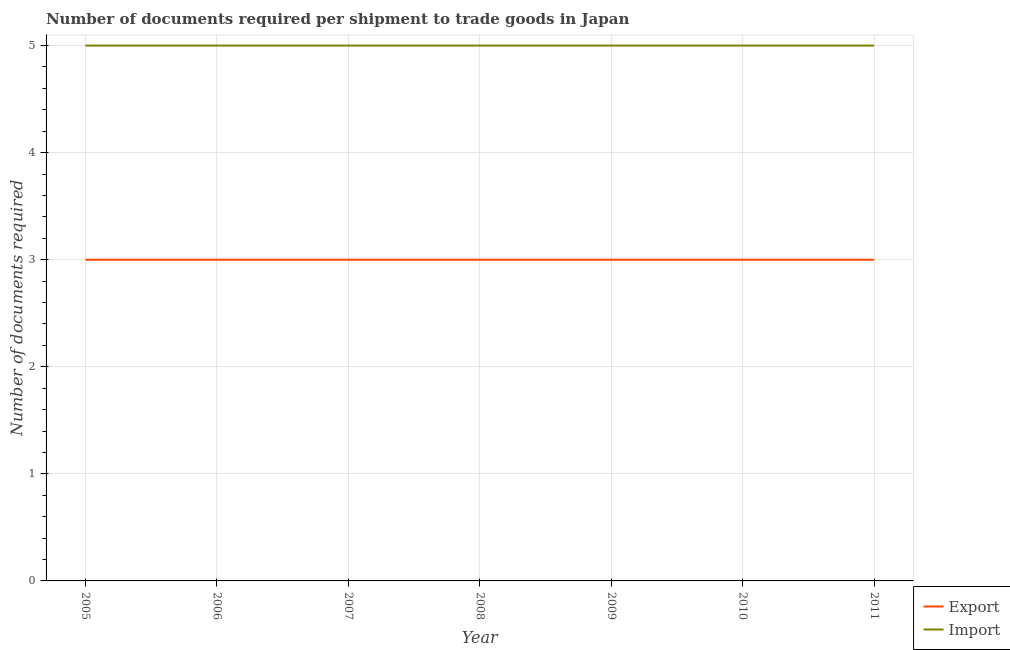Is the number of lines equal to the number of legend labels?
Your answer should be compact. Yes. What is the number of documents required to import goods in 2010?
Give a very brief answer. 5. Across all years, what is the maximum number of documents required to export goods?
Your answer should be compact. 3. Across all years, what is the minimum number of documents required to export goods?
Offer a terse response. 3. What is the total number of documents required to import goods in the graph?
Your answer should be very brief. 35. What is the difference between the number of documents required to import goods in 2010 and the number of documents required to export goods in 2006?
Offer a terse response. 2. What is the average number of documents required to export goods per year?
Your answer should be compact. 3. In the year 2010, what is the difference between the number of documents required to export goods and number of documents required to import goods?
Offer a terse response. -2. What is the ratio of the number of documents required to export goods in 2006 to that in 2008?
Your response must be concise. 1. Is the difference between the number of documents required to import goods in 2006 and 2011 greater than the difference between the number of documents required to export goods in 2006 and 2011?
Ensure brevity in your answer.  No. What is the difference between the highest and the second highest number of documents required to export goods?
Provide a succinct answer. 0. How many lines are there?
Make the answer very short. 2. What is the difference between two consecutive major ticks on the Y-axis?
Ensure brevity in your answer.  1. Are the values on the major ticks of Y-axis written in scientific E-notation?
Give a very brief answer. No. Where does the legend appear in the graph?
Your response must be concise. Bottom right. How many legend labels are there?
Keep it short and to the point. 2. What is the title of the graph?
Your answer should be compact. Number of documents required per shipment to trade goods in Japan. Does "Register a property" appear as one of the legend labels in the graph?
Your answer should be compact. No. What is the label or title of the X-axis?
Ensure brevity in your answer.  Year. What is the label or title of the Y-axis?
Keep it short and to the point. Number of documents required. What is the Number of documents required of Export in 2005?
Offer a terse response. 3. What is the Number of documents required in Export in 2006?
Your answer should be compact. 3. What is the Number of documents required of Import in 2006?
Keep it short and to the point. 5. What is the Number of documents required of Export in 2009?
Offer a very short reply. 3. What is the Number of documents required in Export in 2010?
Offer a terse response. 3. What is the Number of documents required of Export in 2011?
Your response must be concise. 3. Across all years, what is the maximum Number of documents required in Export?
Your answer should be compact. 3. Across all years, what is the minimum Number of documents required of Export?
Ensure brevity in your answer.  3. Across all years, what is the minimum Number of documents required of Import?
Your answer should be compact. 5. What is the total Number of documents required of Import in the graph?
Provide a short and direct response. 35. What is the difference between the Number of documents required in Export in 2005 and that in 2006?
Provide a short and direct response. 0. What is the difference between the Number of documents required in Import in 2005 and that in 2006?
Your answer should be compact. 0. What is the difference between the Number of documents required of Export in 2005 and that in 2007?
Ensure brevity in your answer.  0. What is the difference between the Number of documents required of Import in 2005 and that in 2007?
Your answer should be very brief. 0. What is the difference between the Number of documents required in Export in 2005 and that in 2009?
Give a very brief answer. 0. What is the difference between the Number of documents required in Import in 2005 and that in 2009?
Provide a succinct answer. 0. What is the difference between the Number of documents required in Import in 2005 and that in 2010?
Your answer should be compact. 0. What is the difference between the Number of documents required of Export in 2005 and that in 2011?
Keep it short and to the point. 0. What is the difference between the Number of documents required of Import in 2005 and that in 2011?
Provide a succinct answer. 0. What is the difference between the Number of documents required of Import in 2006 and that in 2007?
Provide a succinct answer. 0. What is the difference between the Number of documents required of Export in 2006 and that in 2009?
Your answer should be very brief. 0. What is the difference between the Number of documents required of Import in 2006 and that in 2010?
Offer a terse response. 0. What is the difference between the Number of documents required of Export in 2007 and that in 2008?
Ensure brevity in your answer.  0. What is the difference between the Number of documents required of Import in 2007 and that in 2008?
Keep it short and to the point. 0. What is the difference between the Number of documents required in Export in 2007 and that in 2010?
Give a very brief answer. 0. What is the difference between the Number of documents required in Import in 2007 and that in 2010?
Make the answer very short. 0. What is the difference between the Number of documents required in Export in 2007 and that in 2011?
Give a very brief answer. 0. What is the difference between the Number of documents required in Import in 2007 and that in 2011?
Make the answer very short. 0. What is the difference between the Number of documents required of Export in 2008 and that in 2009?
Keep it short and to the point. 0. What is the difference between the Number of documents required in Export in 2008 and that in 2010?
Your answer should be compact. 0. What is the difference between the Number of documents required in Export in 2009 and that in 2011?
Your response must be concise. 0. What is the difference between the Number of documents required of Export in 2005 and the Number of documents required of Import in 2007?
Your response must be concise. -2. What is the difference between the Number of documents required of Export in 2005 and the Number of documents required of Import in 2009?
Your response must be concise. -2. What is the difference between the Number of documents required in Export in 2006 and the Number of documents required in Import in 2011?
Keep it short and to the point. -2. What is the difference between the Number of documents required in Export in 2007 and the Number of documents required in Import in 2008?
Provide a succinct answer. -2. What is the difference between the Number of documents required of Export in 2007 and the Number of documents required of Import in 2009?
Your answer should be very brief. -2. What is the difference between the Number of documents required of Export in 2007 and the Number of documents required of Import in 2010?
Your response must be concise. -2. What is the difference between the Number of documents required of Export in 2007 and the Number of documents required of Import in 2011?
Your response must be concise. -2. What is the difference between the Number of documents required of Export in 2008 and the Number of documents required of Import in 2010?
Offer a very short reply. -2. What is the difference between the Number of documents required of Export in 2008 and the Number of documents required of Import in 2011?
Your answer should be very brief. -2. In the year 2009, what is the difference between the Number of documents required in Export and Number of documents required in Import?
Keep it short and to the point. -2. In the year 2011, what is the difference between the Number of documents required in Export and Number of documents required in Import?
Your response must be concise. -2. What is the ratio of the Number of documents required of Import in 2005 to that in 2006?
Provide a short and direct response. 1. What is the ratio of the Number of documents required of Export in 2005 to that in 2007?
Make the answer very short. 1. What is the ratio of the Number of documents required of Import in 2005 to that in 2008?
Keep it short and to the point. 1. What is the ratio of the Number of documents required of Export in 2005 to that in 2010?
Your response must be concise. 1. What is the ratio of the Number of documents required of Import in 2005 to that in 2010?
Ensure brevity in your answer.  1. What is the ratio of the Number of documents required in Import in 2005 to that in 2011?
Provide a succinct answer. 1. What is the ratio of the Number of documents required of Import in 2006 to that in 2007?
Your response must be concise. 1. What is the ratio of the Number of documents required in Export in 2006 to that in 2009?
Keep it short and to the point. 1. What is the ratio of the Number of documents required in Export in 2006 to that in 2010?
Provide a succinct answer. 1. What is the ratio of the Number of documents required in Export in 2006 to that in 2011?
Give a very brief answer. 1. What is the ratio of the Number of documents required in Import in 2006 to that in 2011?
Provide a short and direct response. 1. What is the ratio of the Number of documents required of Import in 2007 to that in 2008?
Your answer should be very brief. 1. What is the ratio of the Number of documents required of Export in 2007 to that in 2009?
Make the answer very short. 1. What is the ratio of the Number of documents required of Import in 2007 to that in 2009?
Offer a very short reply. 1. What is the ratio of the Number of documents required of Export in 2007 to that in 2010?
Give a very brief answer. 1. What is the ratio of the Number of documents required of Import in 2007 to that in 2010?
Ensure brevity in your answer.  1. What is the ratio of the Number of documents required of Import in 2008 to that in 2009?
Offer a terse response. 1. What is the ratio of the Number of documents required of Export in 2008 to that in 2010?
Keep it short and to the point. 1. What is the ratio of the Number of documents required of Export in 2008 to that in 2011?
Give a very brief answer. 1. What is the ratio of the Number of documents required of Import in 2008 to that in 2011?
Keep it short and to the point. 1. What is the ratio of the Number of documents required of Export in 2009 to that in 2011?
Your response must be concise. 1. What is the ratio of the Number of documents required of Export in 2010 to that in 2011?
Offer a very short reply. 1. What is the ratio of the Number of documents required of Import in 2010 to that in 2011?
Keep it short and to the point. 1. What is the difference between the highest and the second highest Number of documents required of Import?
Keep it short and to the point. 0. 